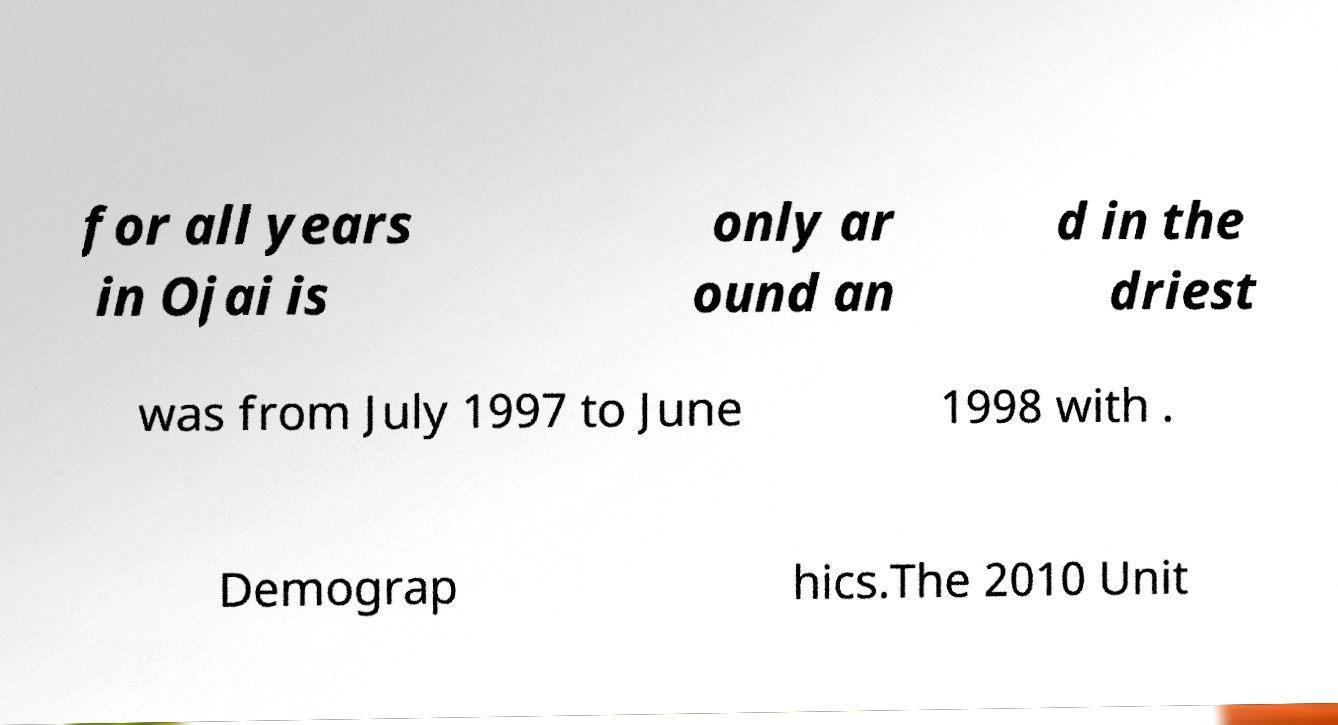Could you assist in decoding the text presented in this image and type it out clearly? for all years in Ojai is only ar ound an d in the driest was from July 1997 to June 1998 with . Demograp hics.The 2010 Unit 